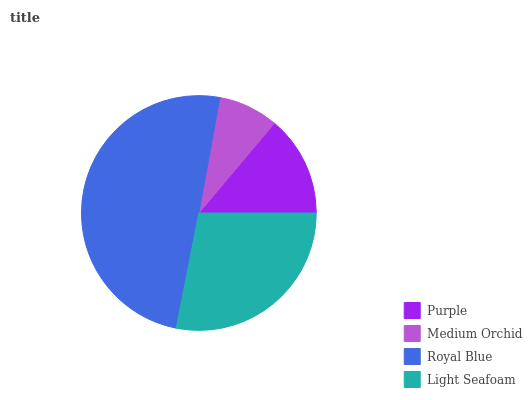Is Medium Orchid the minimum?
Answer yes or no. Yes. Is Royal Blue the maximum?
Answer yes or no. Yes. Is Royal Blue the minimum?
Answer yes or no. No. Is Medium Orchid the maximum?
Answer yes or no. No. Is Royal Blue greater than Medium Orchid?
Answer yes or no. Yes. Is Medium Orchid less than Royal Blue?
Answer yes or no. Yes. Is Medium Orchid greater than Royal Blue?
Answer yes or no. No. Is Royal Blue less than Medium Orchid?
Answer yes or no. No. Is Light Seafoam the high median?
Answer yes or no. Yes. Is Purple the low median?
Answer yes or no. Yes. Is Medium Orchid the high median?
Answer yes or no. No. Is Royal Blue the low median?
Answer yes or no. No. 